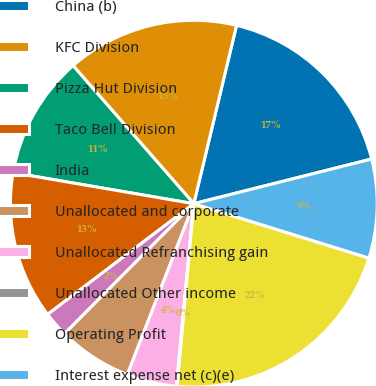Convert chart. <chart><loc_0><loc_0><loc_500><loc_500><pie_chart><fcel>China (b)<fcel>KFC Division<fcel>Pizza Hut Division<fcel>Taco Bell Division<fcel>India<fcel>Unallocated and corporate<fcel>Unallocated Refranchising gain<fcel>Unallocated Other income<fcel>Operating Profit<fcel>Interest expense net (c)(e)<nl><fcel>17.34%<fcel>15.18%<fcel>10.86%<fcel>13.02%<fcel>2.23%<fcel>6.55%<fcel>4.39%<fcel>0.07%<fcel>21.65%<fcel>8.71%<nl></chart> 